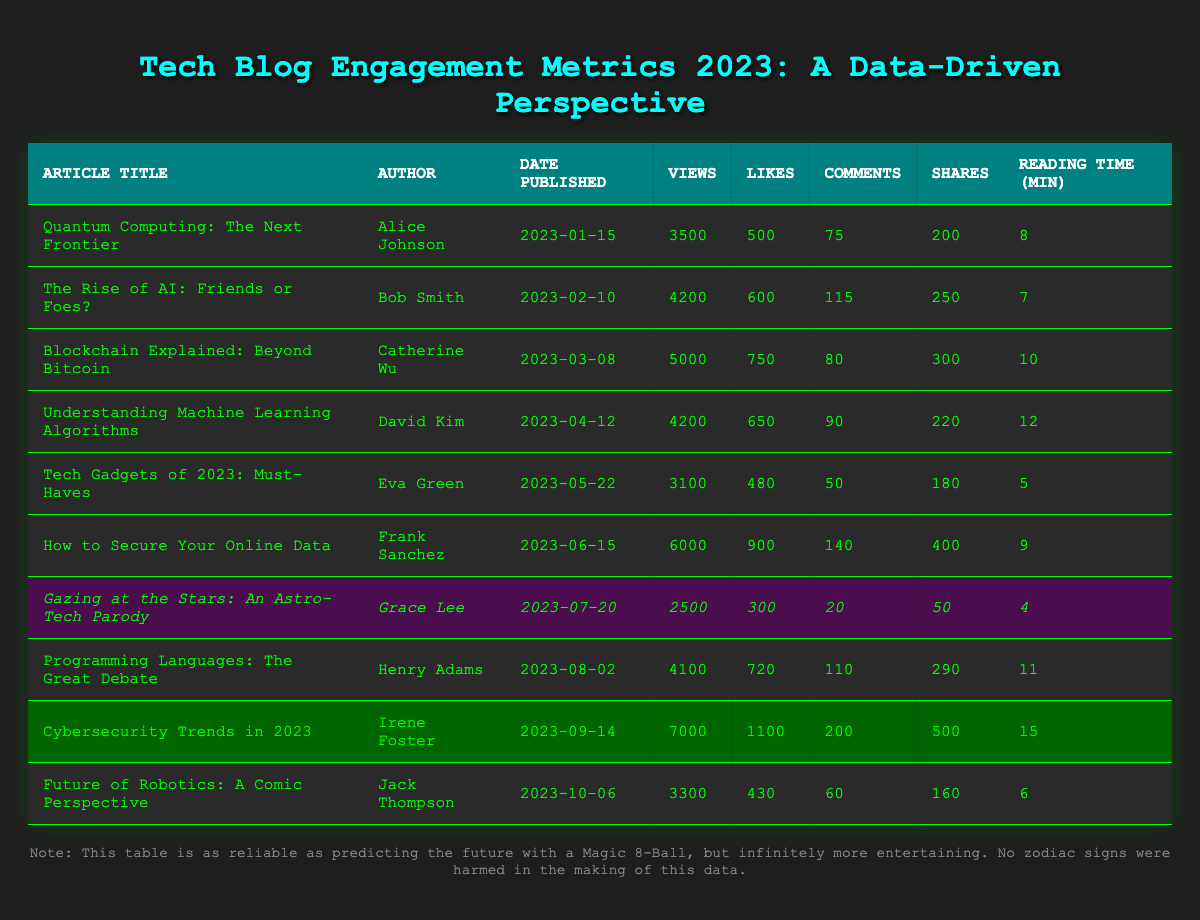What is the article with the highest number of views? The article with the highest number of views is "Cybersecurity Trends in 2023," which has 7000 views.
Answer: Cybersecurity Trends in 2023 Which article was authored by Grace Lee? The article authored by Grace Lee is "Gazing at the Stars: An Astro-Tech Parody."
Answer: Gazing at the Stars: An Astro-Tech Parody What is the total number of likes for articles published by Bob Smith and Frank Sanchez? Bob Smith's article has 600 likes, and Frank Sanchez's article has 900 likes; adding them gives 600 + 900 = 1500 likes.
Answer: 1500 How many articles have been published after June 1, 2023? The articles published after June 1, 2023, are "Gazing at the Stars: An Astro-Tech Parody," "Programming Languages: The Great Debate," "Cybersecurity Trends in 2023," and "Future of Robotics: A Comic Perspective." This totals to 4 articles.
Answer: 4 Did any articles receive more than 100 shares? Yes, both "How to Secure Your Online Data" and "Cybersecurity Trends in 2023" received more than 100 shares.
Answer: Yes What is the average reading time of articles authored by David Kim and Irene Foster? David Kim's article has 12 minutes of reading time and Irene Foster's article has 15 minutes. To find the average, we calculate (12 + 15) / 2 = 13.5 minutes.
Answer: 13.5 Which article has the least number of comments and what is that number? The article with the least number of comments is "Gazing at the Stars: An Astro-Tech Parody," which has 20 comments.
Answer: 20 What was the difference in views between the articles "Tech Gadgets of 2023: Must-Haves" and "How to Secure Your Online Data"? "Tech Gadgets of 2023: Must-Haves" has 3100 views, and "How to Secure Your Online Data" has 6000 views. The difference is 6000 - 3100 = 2900 views.
Answer: 2900 How many comments did "Blockchain Explained: Beyond Bitcoin" receive compared to "Understanding Machine Learning Algorithms"? "Blockchain Explained: Beyond Bitcoin" received 80 comments, while "Understanding Machine Learning Algorithms" received 90 comments. The difference is 90 - 80 = 10 more comments for the latter.
Answer: 10 more comments for Understanding Machine Learning Algorithms 